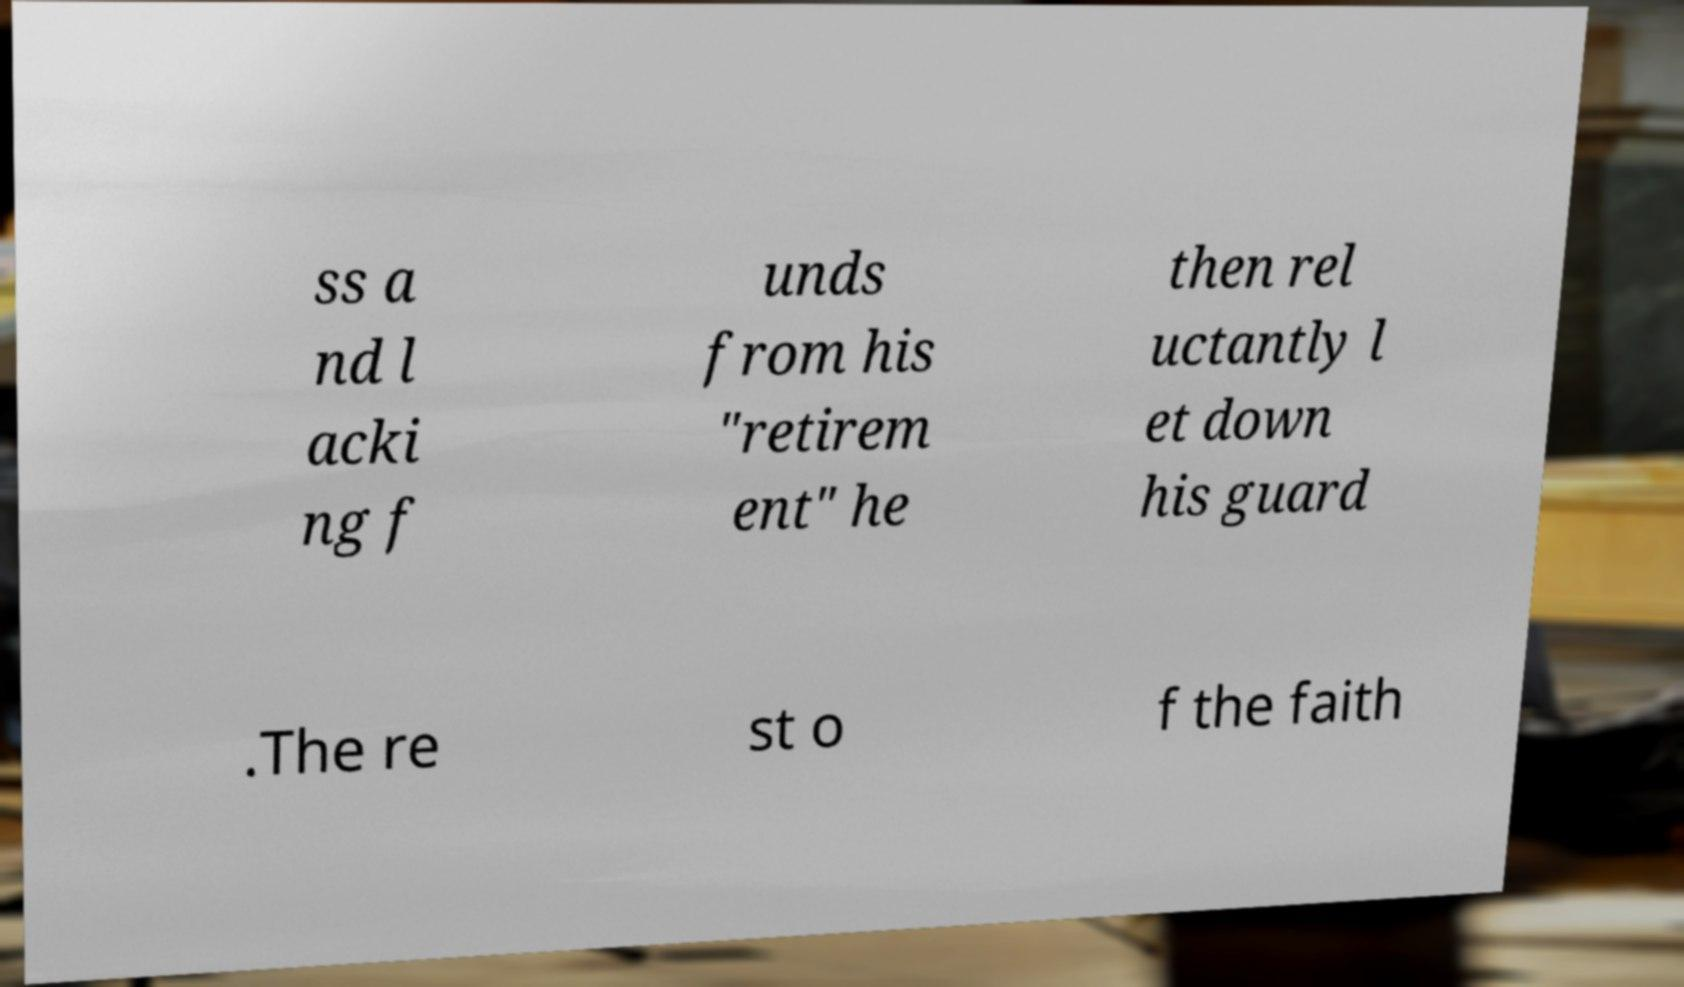Could you extract and type out the text from this image? ss a nd l acki ng f unds from his "retirem ent" he then rel uctantly l et down his guard .The re st o f the faith 